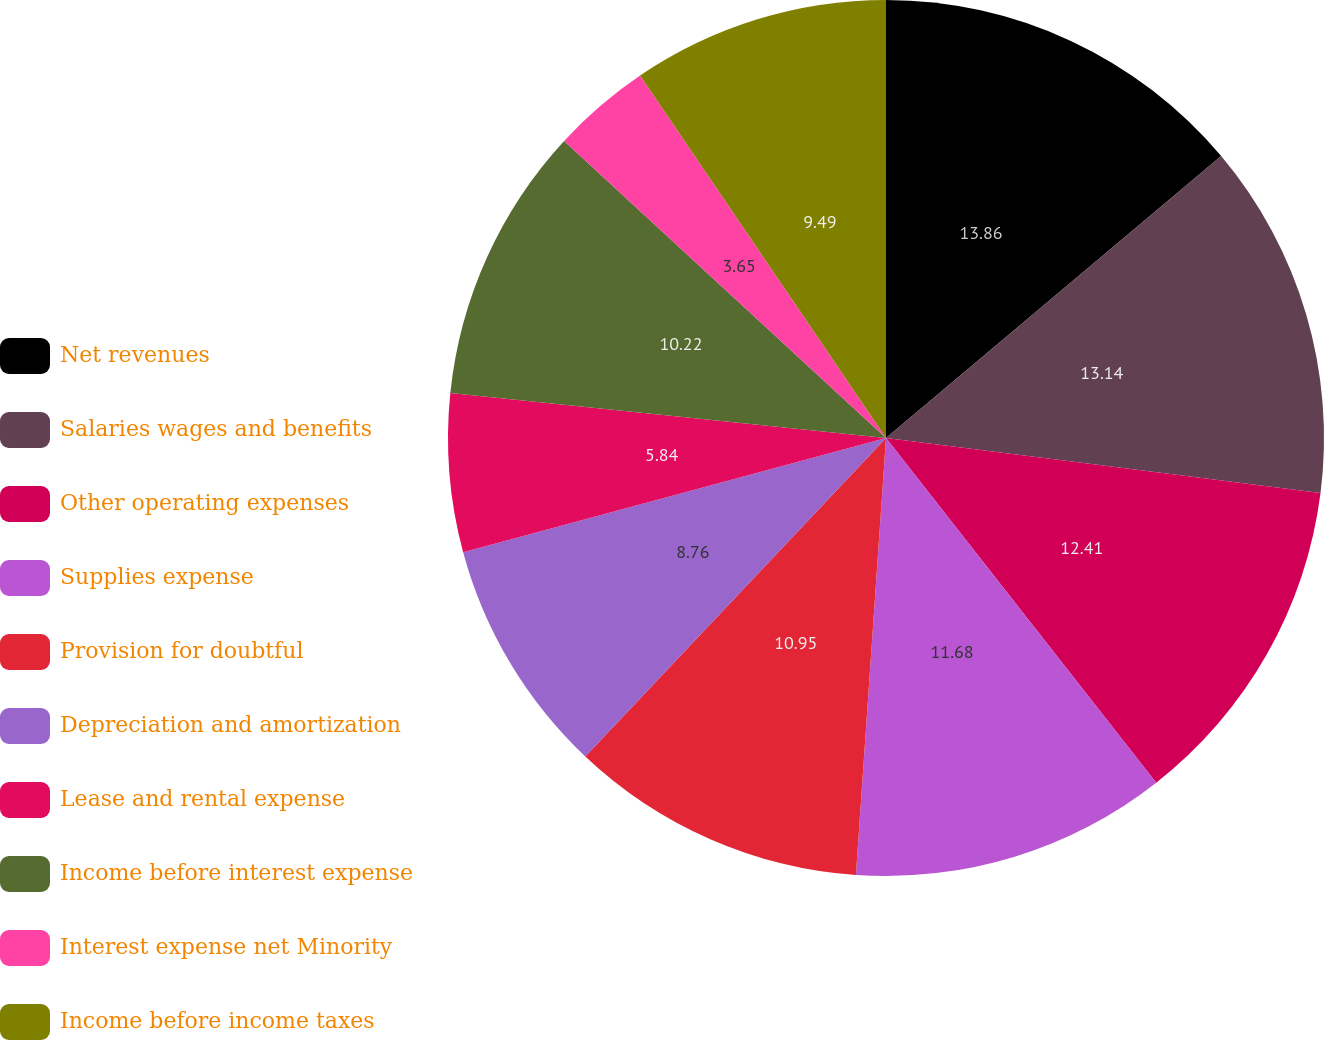<chart> <loc_0><loc_0><loc_500><loc_500><pie_chart><fcel>Net revenues<fcel>Salaries wages and benefits<fcel>Other operating expenses<fcel>Supplies expense<fcel>Provision for doubtful<fcel>Depreciation and amortization<fcel>Lease and rental expense<fcel>Income before interest expense<fcel>Interest expense net Minority<fcel>Income before income taxes<nl><fcel>13.87%<fcel>13.14%<fcel>12.41%<fcel>11.68%<fcel>10.95%<fcel>8.76%<fcel>5.84%<fcel>10.22%<fcel>3.65%<fcel>9.49%<nl></chart> 